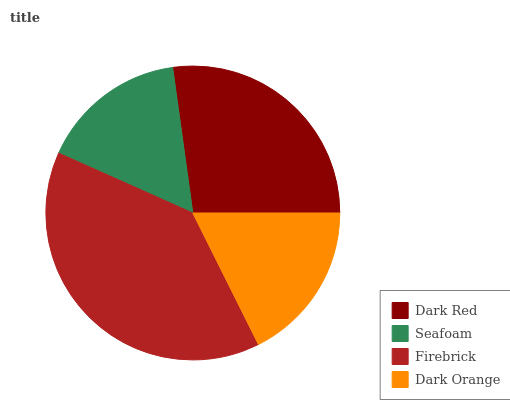Is Seafoam the minimum?
Answer yes or no. Yes. Is Firebrick the maximum?
Answer yes or no. Yes. Is Firebrick the minimum?
Answer yes or no. No. Is Seafoam the maximum?
Answer yes or no. No. Is Firebrick greater than Seafoam?
Answer yes or no. Yes. Is Seafoam less than Firebrick?
Answer yes or no. Yes. Is Seafoam greater than Firebrick?
Answer yes or no. No. Is Firebrick less than Seafoam?
Answer yes or no. No. Is Dark Red the high median?
Answer yes or no. Yes. Is Dark Orange the low median?
Answer yes or no. Yes. Is Seafoam the high median?
Answer yes or no. No. Is Dark Red the low median?
Answer yes or no. No. 